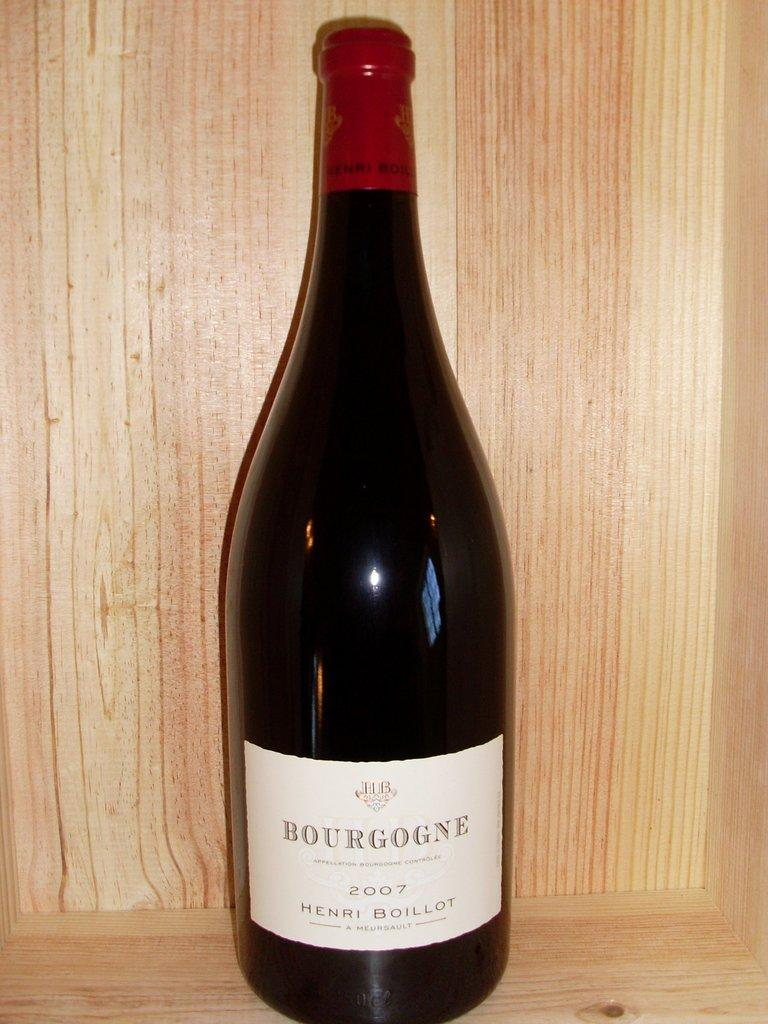Provide a one-sentence caption for the provided image. A bottle of  2007 Bourgogne sitting on a shelf. 